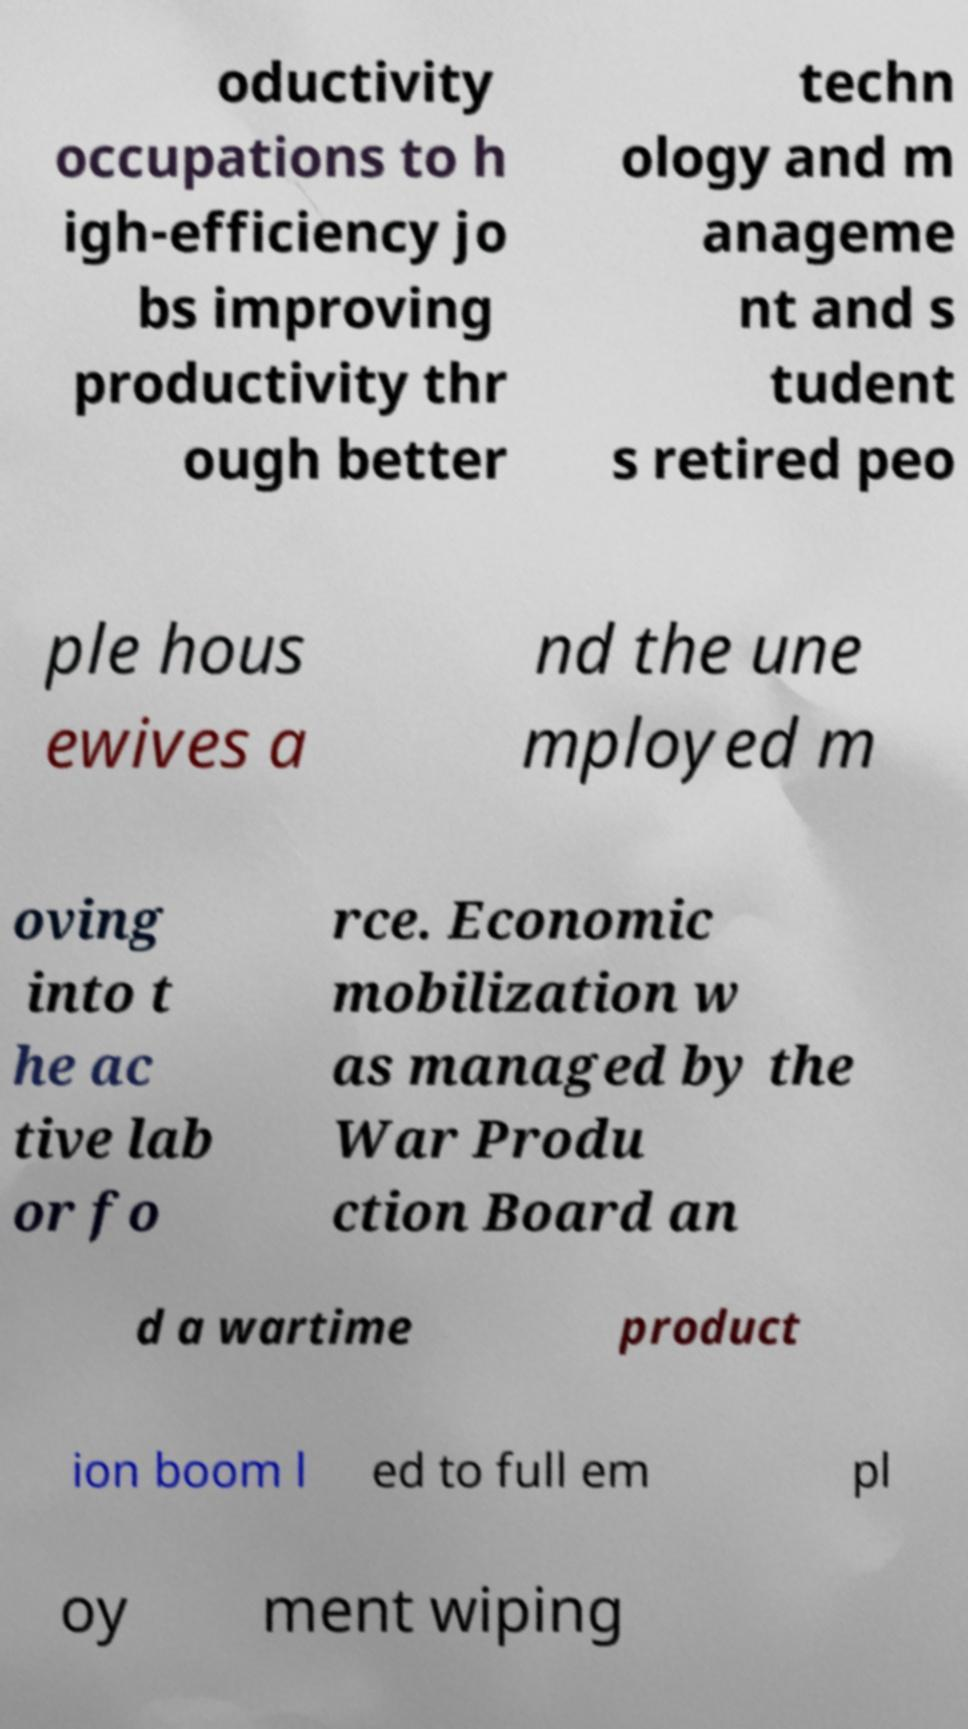Can you accurately transcribe the text from the provided image for me? oductivity occupations to h igh-efficiency jo bs improving productivity thr ough better techn ology and m anageme nt and s tudent s retired peo ple hous ewives a nd the une mployed m oving into t he ac tive lab or fo rce. Economic mobilization w as managed by the War Produ ction Board an d a wartime product ion boom l ed to full em pl oy ment wiping 